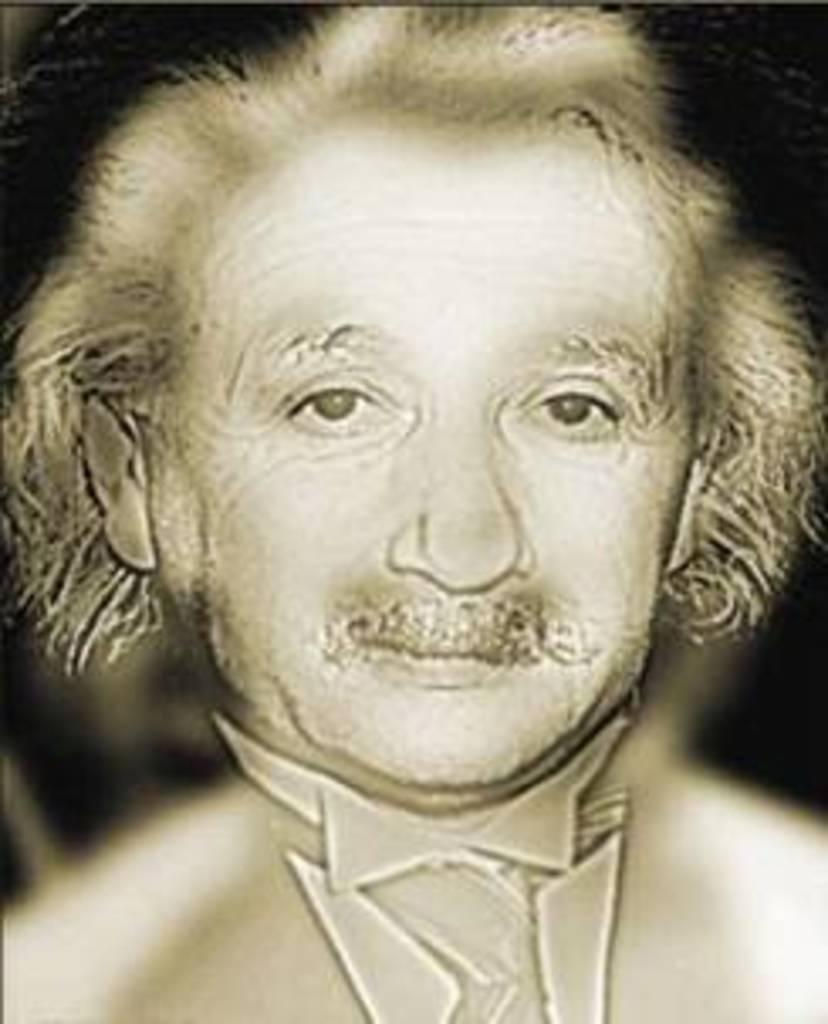Describe this image in one or two sentences. In this image we can see painting of a person. 